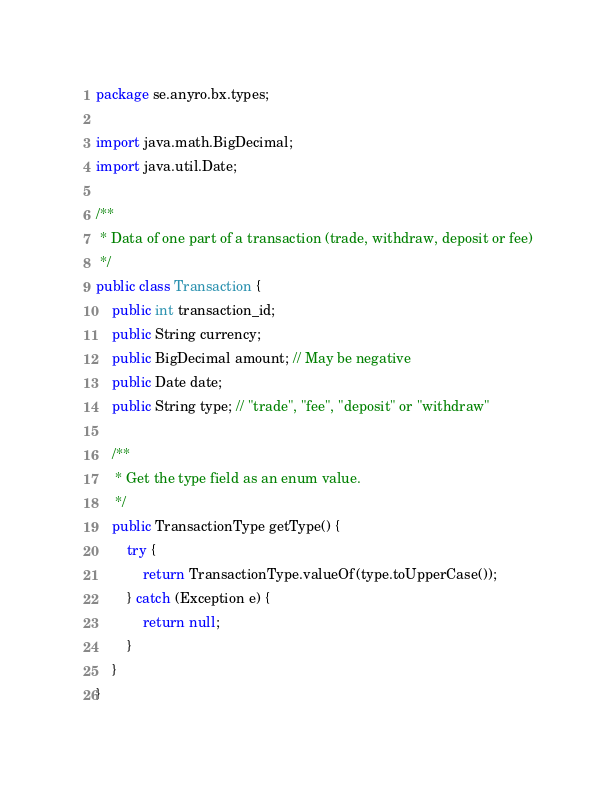Convert code to text. <code><loc_0><loc_0><loc_500><loc_500><_Java_>package se.anyro.bx.types;

import java.math.BigDecimal;
import java.util.Date;

/**
 * Data of one part of a transaction (trade, withdraw, deposit or fee)
 */
public class Transaction {
    public int transaction_id;
    public String currency;
    public BigDecimal amount; // May be negative
    public Date date;
    public String type; // "trade", "fee", "deposit" or "withdraw"

    /**
     * Get the type field as an enum value.
     */
    public TransactionType getType() {
        try {
            return TransactionType.valueOf(type.toUpperCase());
        } catch (Exception e) {
            return null;
        }
    }
}</code> 